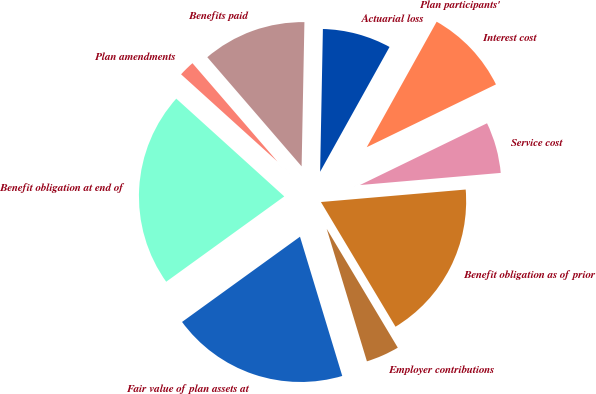<chart> <loc_0><loc_0><loc_500><loc_500><pie_chart><fcel>Benefit obligation as of prior<fcel>Service cost<fcel>Interest cost<fcel>Plan participants'<fcel>Actuarial loss<fcel>Benefits paid<fcel>Plan amendments<fcel>Benefit obligation at end of<fcel>Fair value of plan assets at<fcel>Employer contributions<nl><fcel>17.79%<fcel>5.83%<fcel>9.71%<fcel>0.01%<fcel>7.77%<fcel>11.65%<fcel>1.95%<fcel>21.67%<fcel>19.73%<fcel>3.89%<nl></chart> 